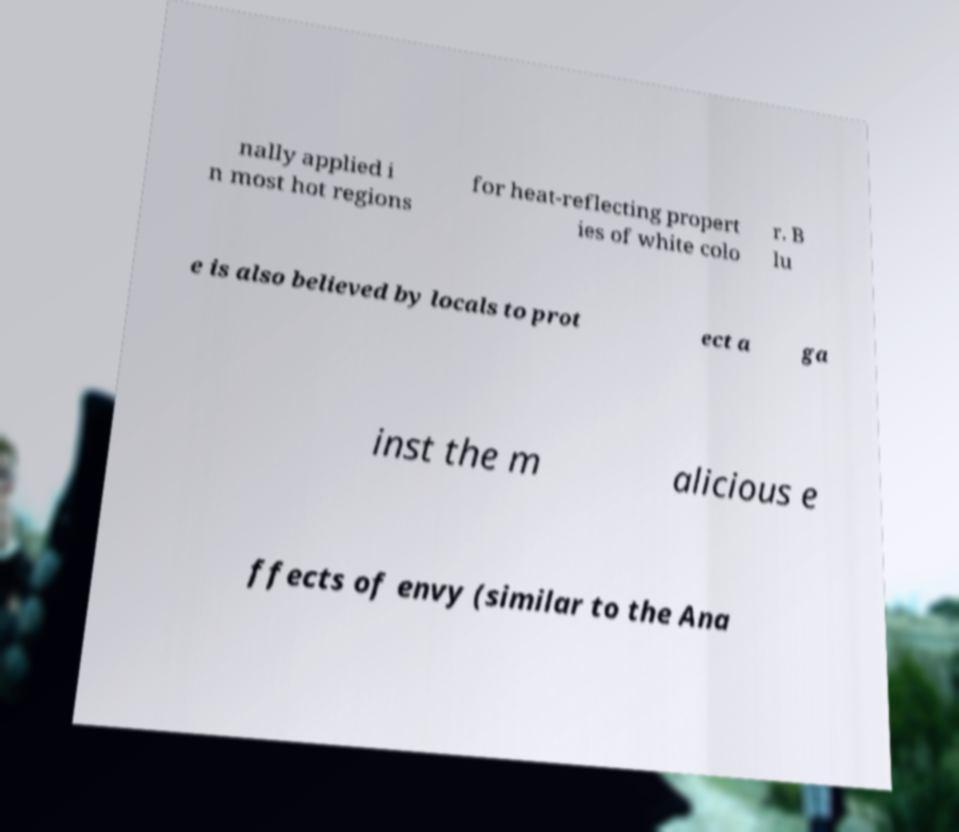Could you extract and type out the text from this image? nally applied i n most hot regions for heat-reflecting propert ies of white colo r. B lu e is also believed by locals to prot ect a ga inst the m alicious e ffects of envy (similar to the Ana 